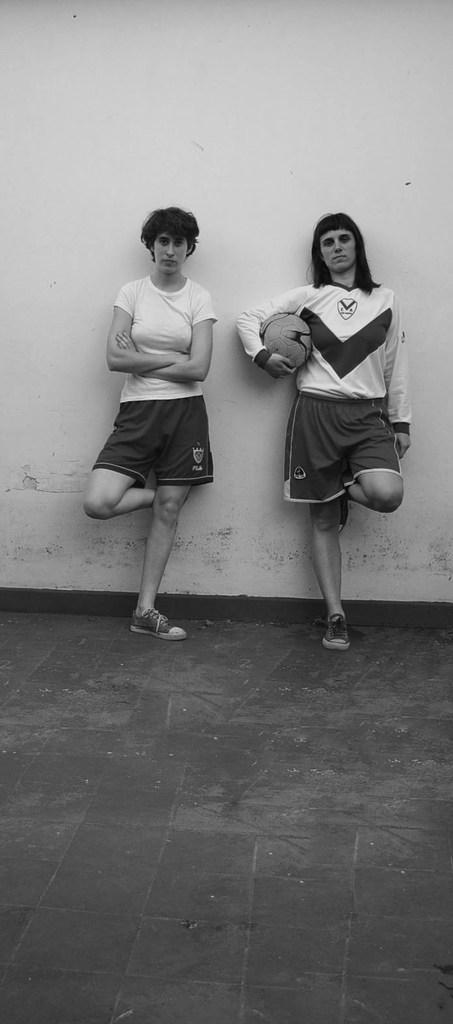What is the color scheme of the image? The image is black and white. How many people are present in the image? There are two people in the image. What is one of the people holding? One of the people is holding a ball. What can be seen in the background of the image? There is a wall in the background of the image. What is visible at the bottom of the image? There is a floor visible at the bottom of the image. What type of stew is being served on the tray in the image? There is no tray or stew present in the image. How many bites has the person taken out of the ball in the image? There is no indication that the person has taken any bites out of the ball, as it is likely a solid object and not food. 